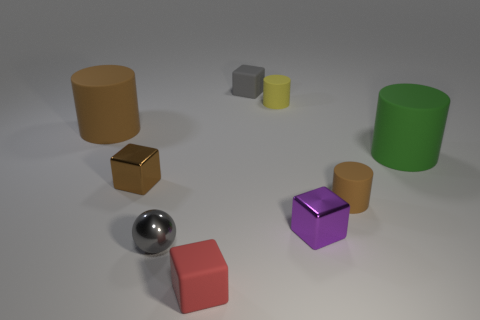There is a big thing that is right of the gray thing that is behind the purple block; how many small things are to the left of it?
Ensure brevity in your answer.  7. Is the yellow object the same shape as the small gray shiny thing?
Ensure brevity in your answer.  No. Are there any small blue shiny things of the same shape as the small gray matte object?
Make the answer very short. No. What shape is the gray rubber thing that is the same size as the red object?
Your response must be concise. Cube. There is a large cylinder to the left of the large rubber object that is in front of the large object that is on the left side of the red rubber cube; what is it made of?
Offer a terse response. Rubber. Does the gray rubber block have the same size as the brown metallic cube?
Your response must be concise. Yes. What is the tiny yellow thing made of?
Ensure brevity in your answer.  Rubber. There is a block that is the same color as the small ball; what material is it?
Offer a terse response. Rubber. Do the big matte object right of the gray sphere and the red rubber thing have the same shape?
Your answer should be compact. No. How many things are either tiny red rubber blocks or big brown shiny blocks?
Ensure brevity in your answer.  1. 